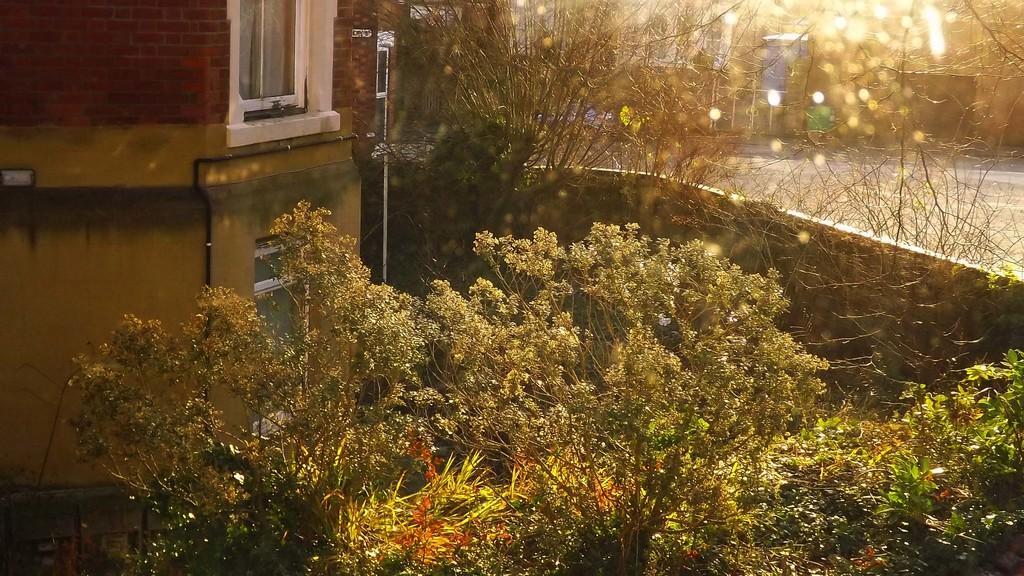In one or two sentences, can you explain what this image depicts? We can see trees, building and wall. In the background it is blur. 